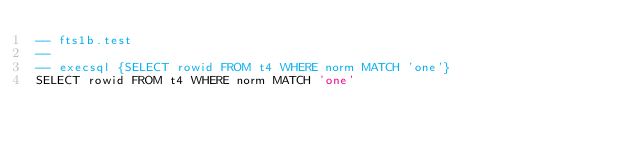<code> <loc_0><loc_0><loc_500><loc_500><_SQL_>-- fts1b.test
-- 
-- execsql {SELECT rowid FROM t4 WHERE norm MATCH 'one'}
SELECT rowid FROM t4 WHERE norm MATCH 'one'</code> 